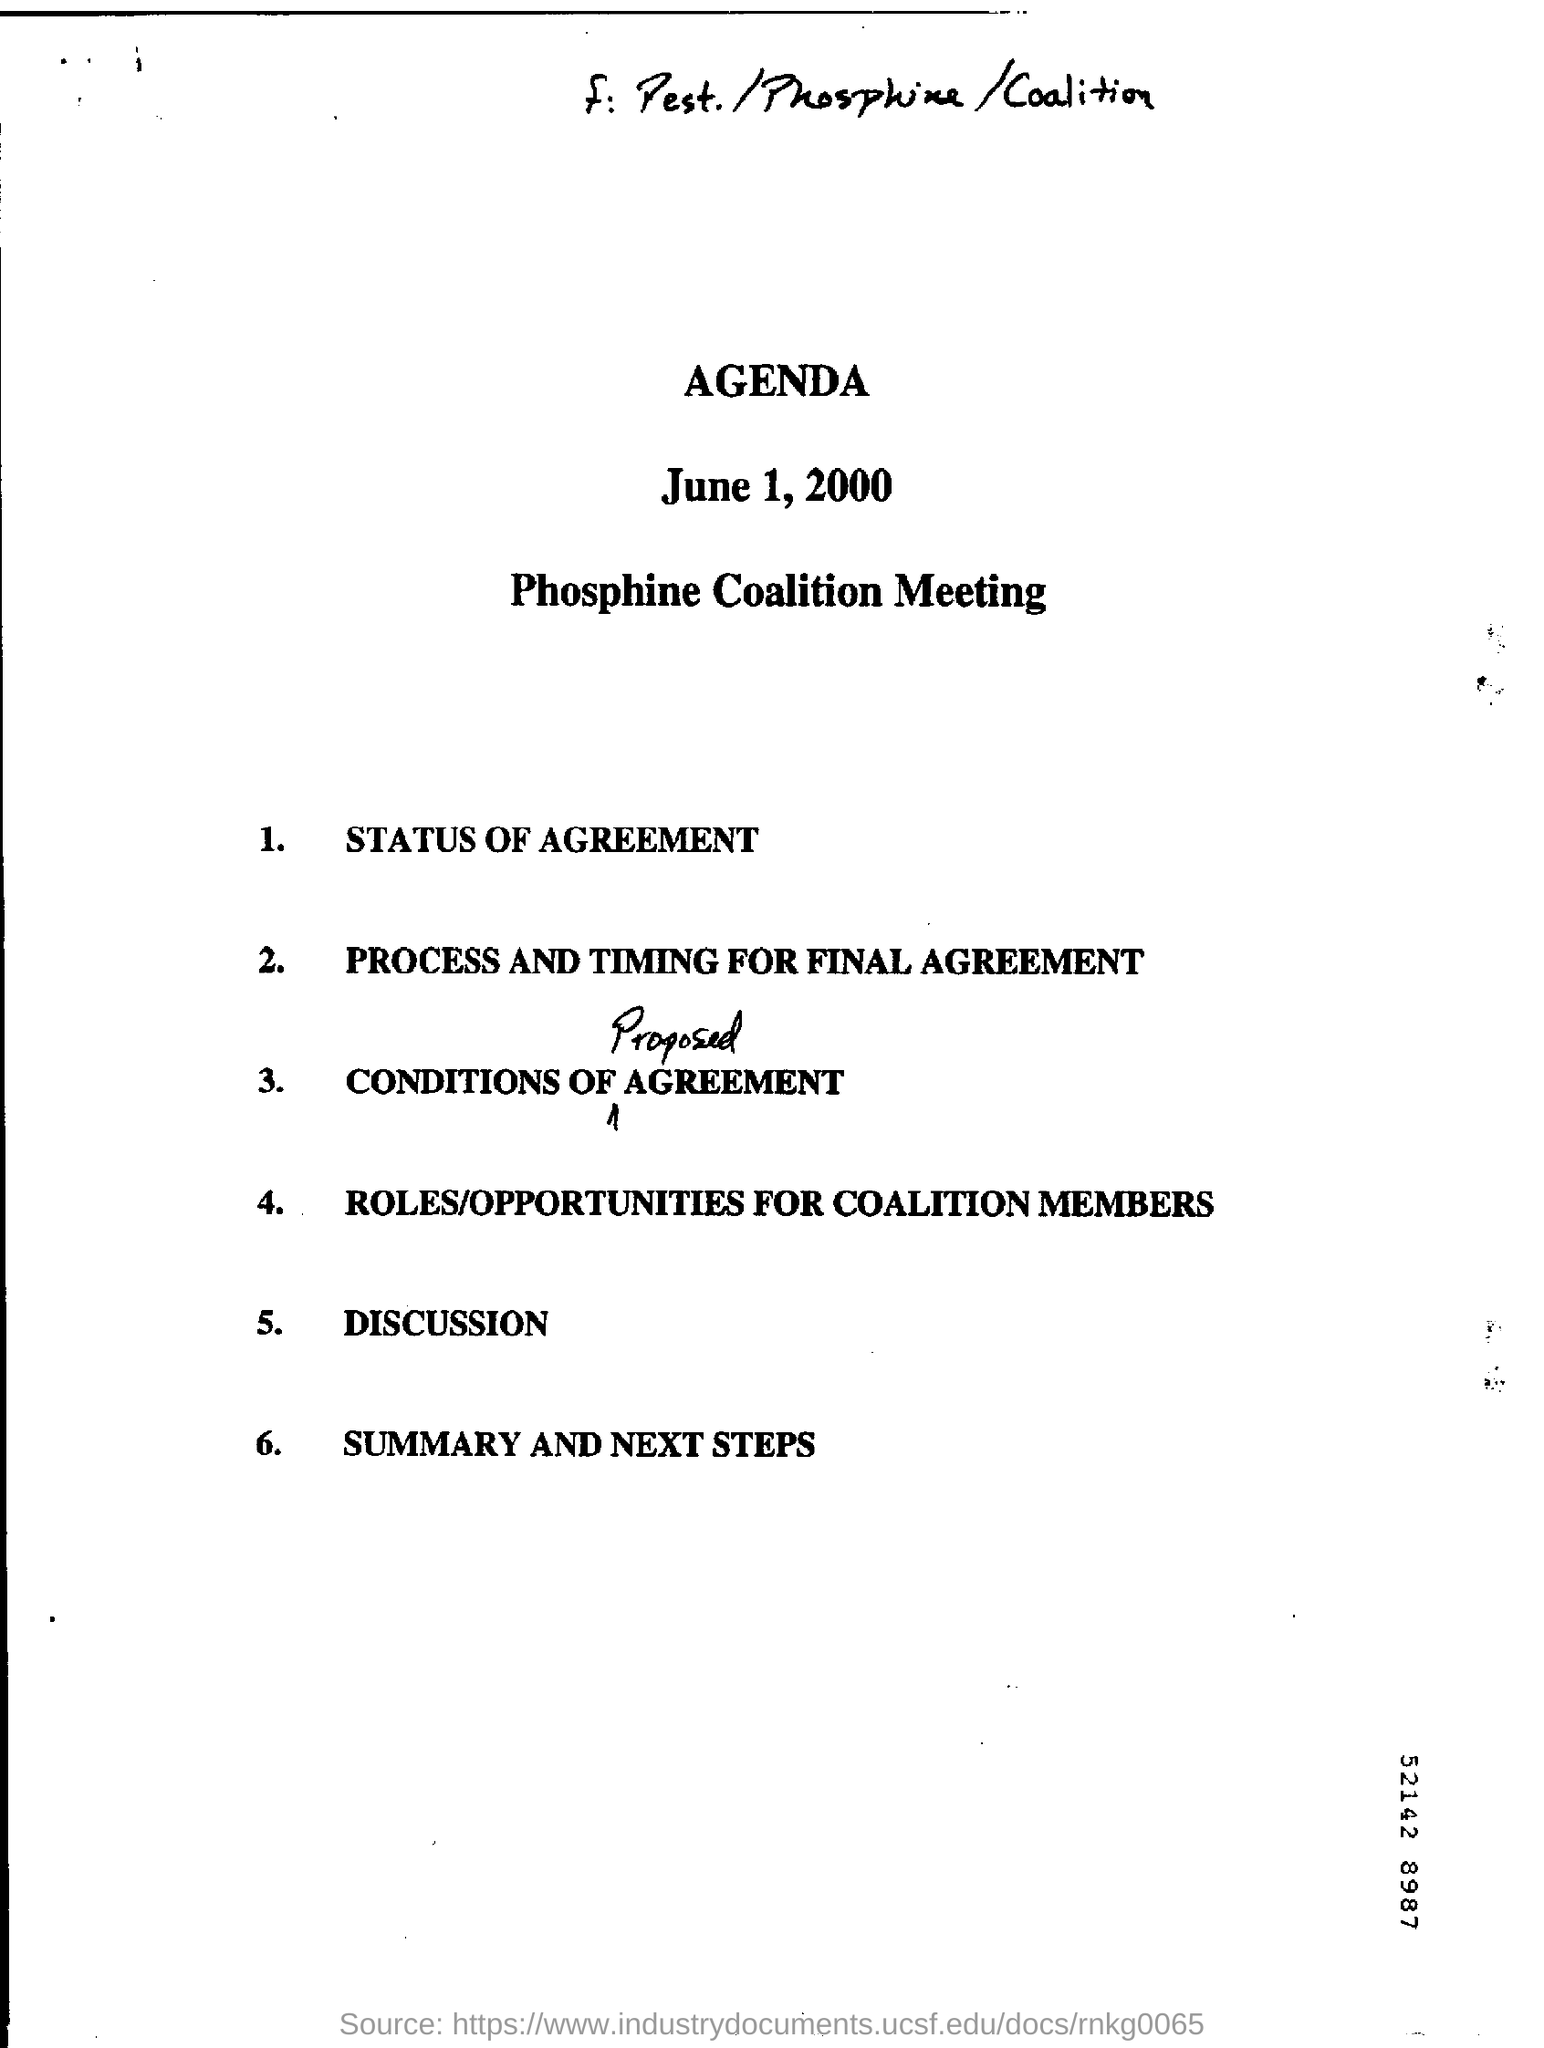What does the heading say?
Offer a terse response. AGENDA. What is the fifth point of the Agenda?
Offer a very short reply. DISCUSSION. What is the handwritten word in the third point?
Your response must be concise. PROPOSED. 